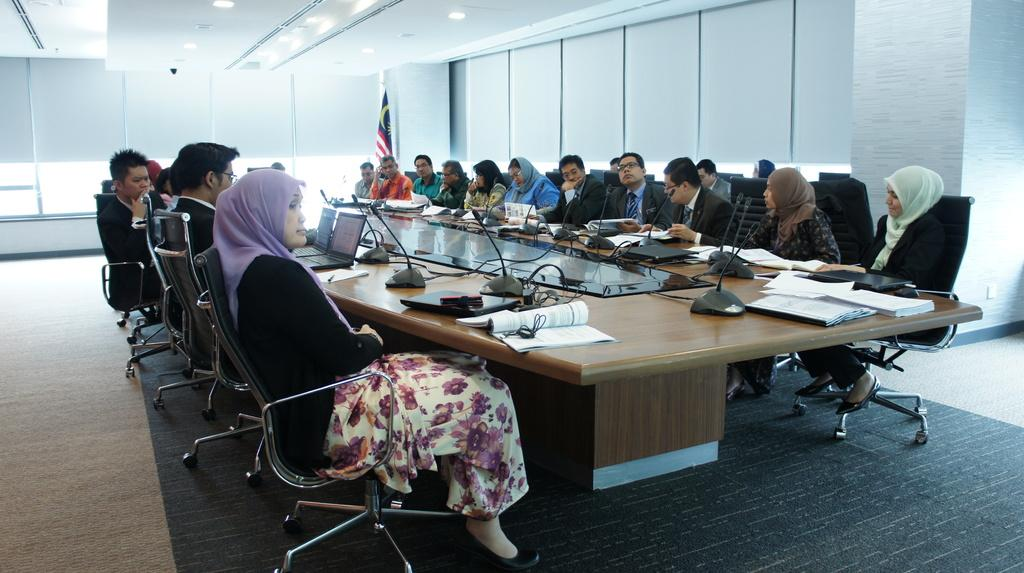What type of space is depicted in the image? There is a room in the image. What furniture is present in the room? There is a chair and a table in the room. What items can be seen on the table? There is a laptop, a book, and a microphone board on the table. What can be seen in the background of the image? There is a flag, a window, and lights visible in the background. What type of potato is being used as a microphone in the image? There is no potato present in the image, and the microphone board is not made of a potato. What nation is represented by the flag in the image? The image does not show a specific flag, so it is not possible to determine which nation it represents. 